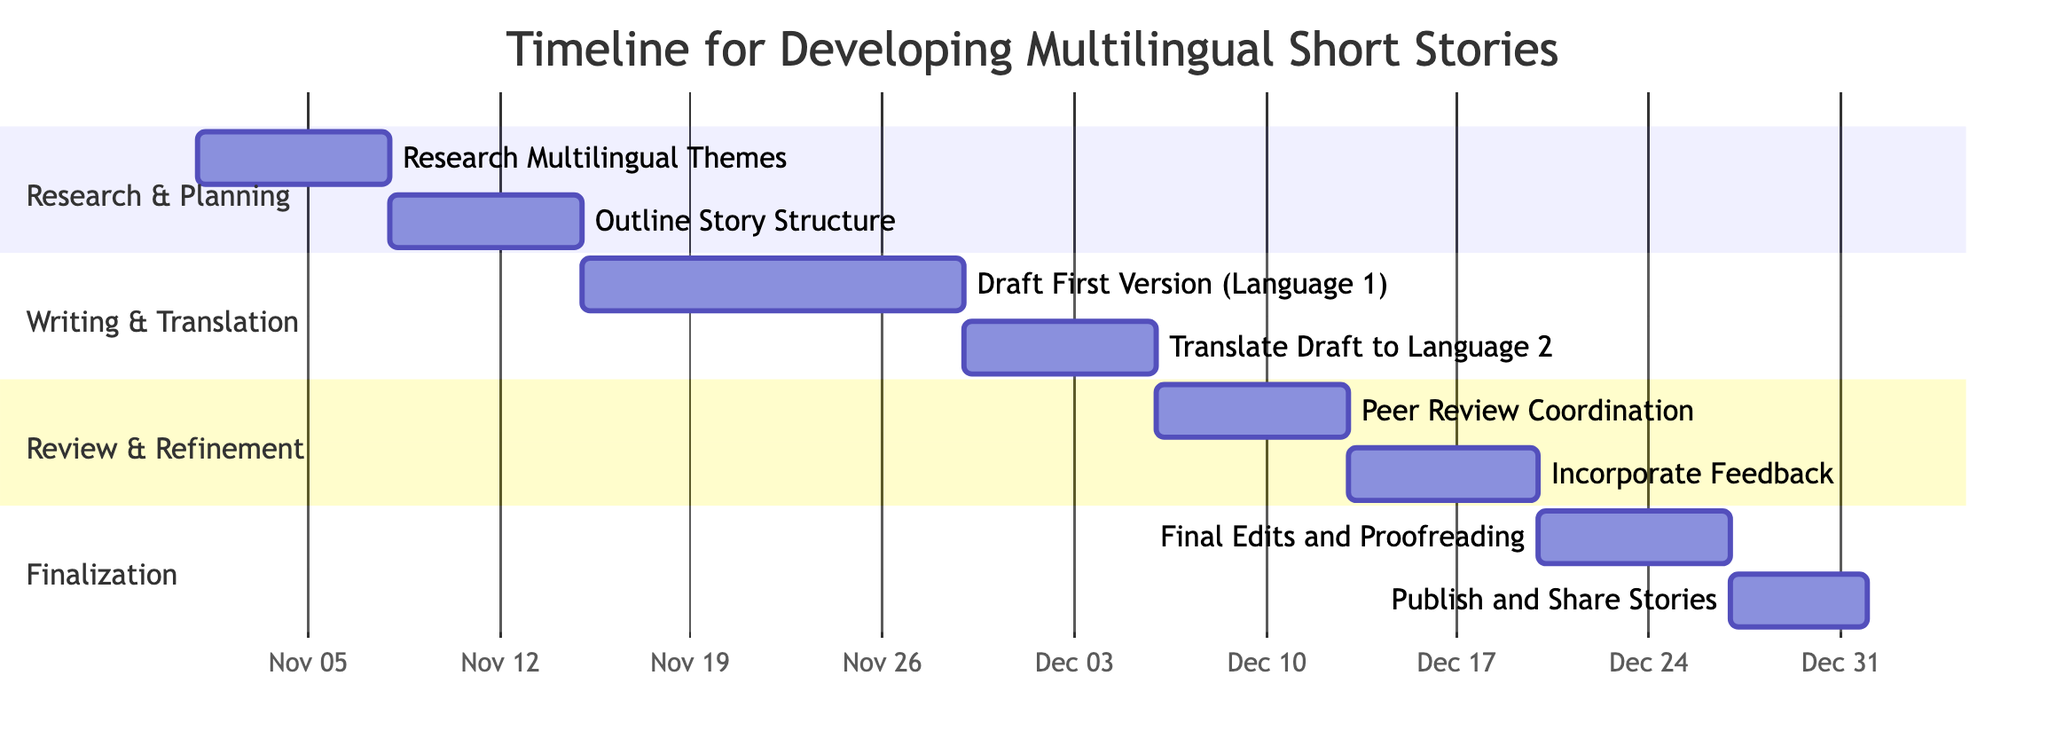What is the duration for drafting the first version of the story? The task "Draft First Version (Language 1)" lasts from November 15 to November 28, which is a total of 14 days.
Answer: 14 days Which task follows the "Translate Draft to Language 2"? The "Translate Draft to Language 2" ends on December 5, and the next task listed in the diagram is "Peer Review Coordination," which starts on December 6.
Answer: Peer Review Coordination How many tasks are there in the "Review & Refinement" section? There are two tasks in the "Review & Refinement" section: "Peer Review Coordination" and "Incorporate Feedback."
Answer: 2 What is the starting date of the task for final edits and proofreading? The task "Final Edits and Proofreading" starts on December 20 according to the timeline in the diagram.
Answer: December 20 Which section contains the task for outlining story structure? The task "Outline Story Structure" is located in the "Research & Planning" section of the diagram.
Answer: Research & Planning How many days are allocated for publishing and sharing stories? The task "Publish and Share Stories" is set for 5 days, from December 27 to December 31.
Answer: 5 days What is the end date for the task that involves incorporating feedback? The task "Incorporate Feedback" ends on December 19, as indicated in the timeline.
Answer: December 19 Which task comes immediately after "Research Multilingual Themes"? The task that immediately follows "Research Multilingual Themes" is "Outline Story Structure," beginning on November 8.
Answer: Outline Story Structure 